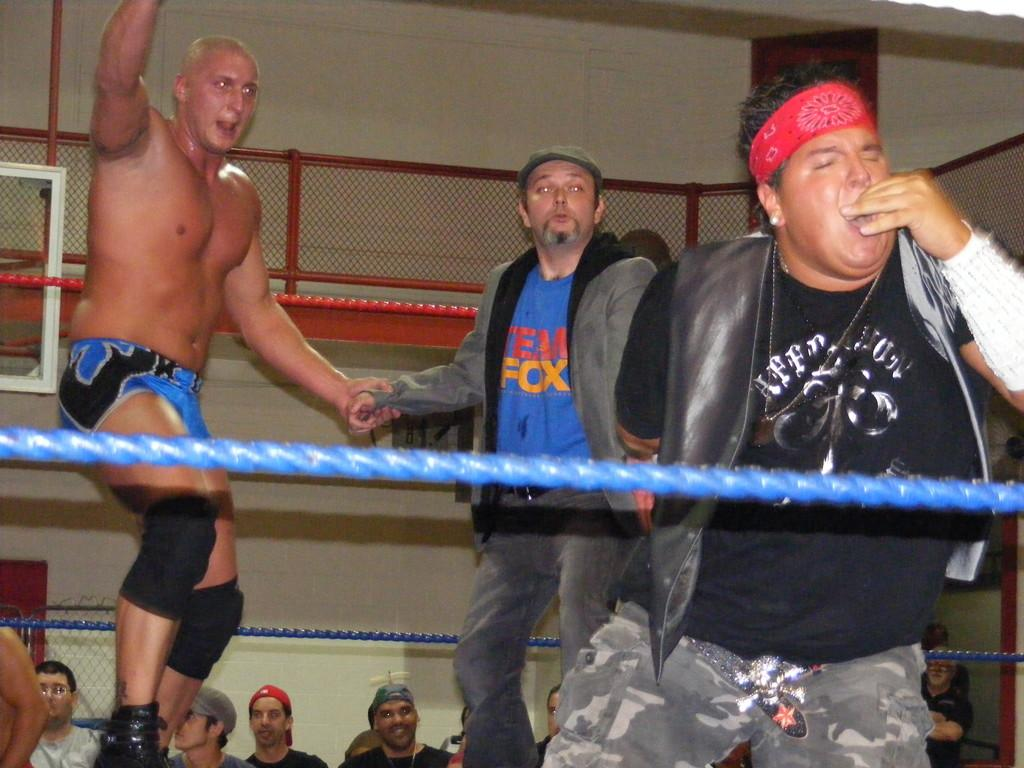<image>
Offer a succinct explanation of the picture presented. a blue shirt on a person that says Fox on it 